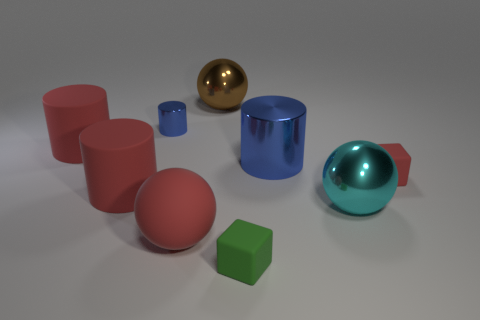What number of other objects are the same size as the brown thing?
Your answer should be very brief. 5. What is the size of the brown sphere that is the same material as the big cyan ball?
Your answer should be compact. Large. There is a cyan ball; does it have the same size as the blue shiny thing on the right side of the big brown metallic object?
Give a very brief answer. Yes. The big thing that is behind the big cyan metal thing and right of the green thing is what color?
Provide a short and direct response. Blue. How many objects are either large red objects that are behind the tiny red matte thing or things to the right of the brown metallic object?
Provide a succinct answer. 5. What is the color of the big ball that is behind the metallic cylinder that is left of the blue shiny cylinder in front of the small blue metal cylinder?
Ensure brevity in your answer.  Brown. Are there any other large brown things of the same shape as the big brown metallic thing?
Offer a terse response. No. What number of small green blocks are there?
Provide a short and direct response. 1. What is the shape of the large brown object?
Make the answer very short. Sphere. What number of other brown things are the same size as the brown thing?
Your response must be concise. 0. 